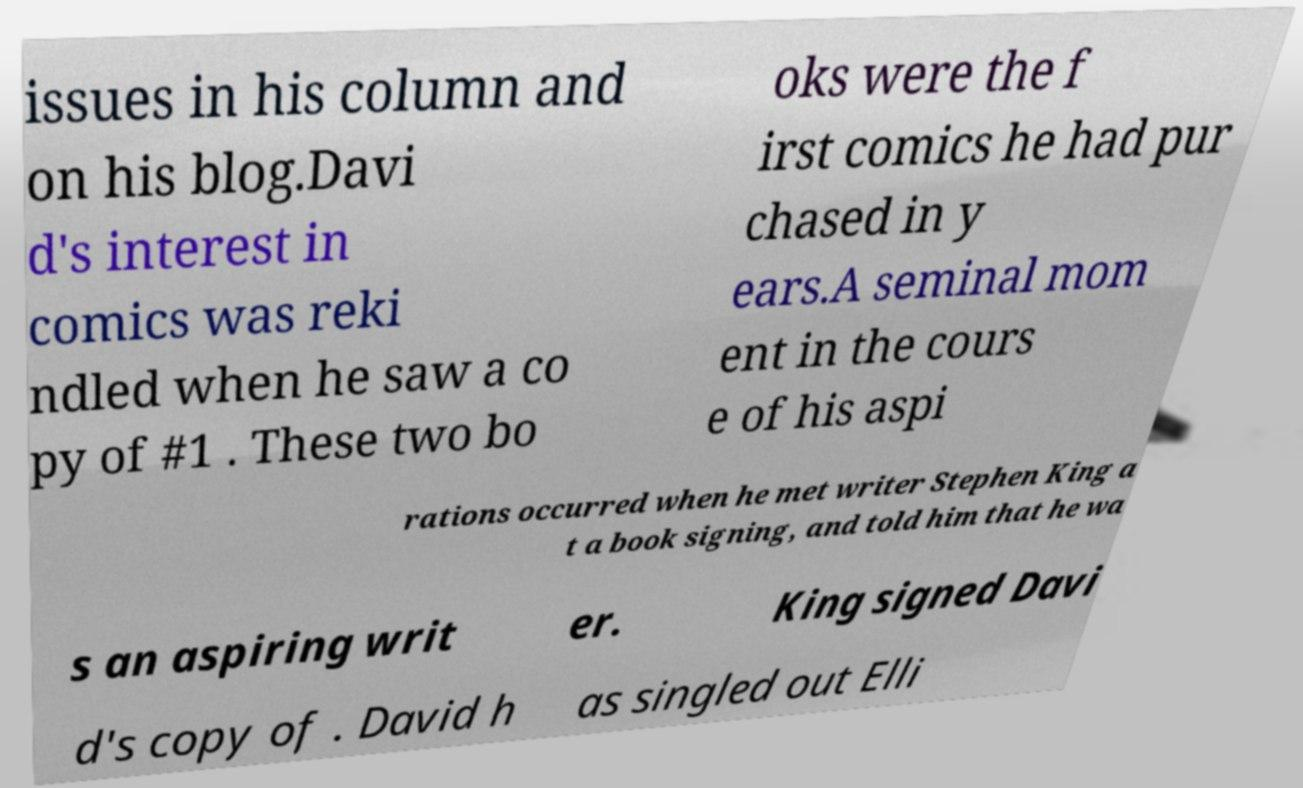Please read and relay the text visible in this image. What does it say? issues in his column and on his blog.Davi d's interest in comics was reki ndled when he saw a co py of #1 . These two bo oks were the f irst comics he had pur chased in y ears.A seminal mom ent in the cours e of his aspi rations occurred when he met writer Stephen King a t a book signing, and told him that he wa s an aspiring writ er. King signed Davi d's copy of . David h as singled out Elli 